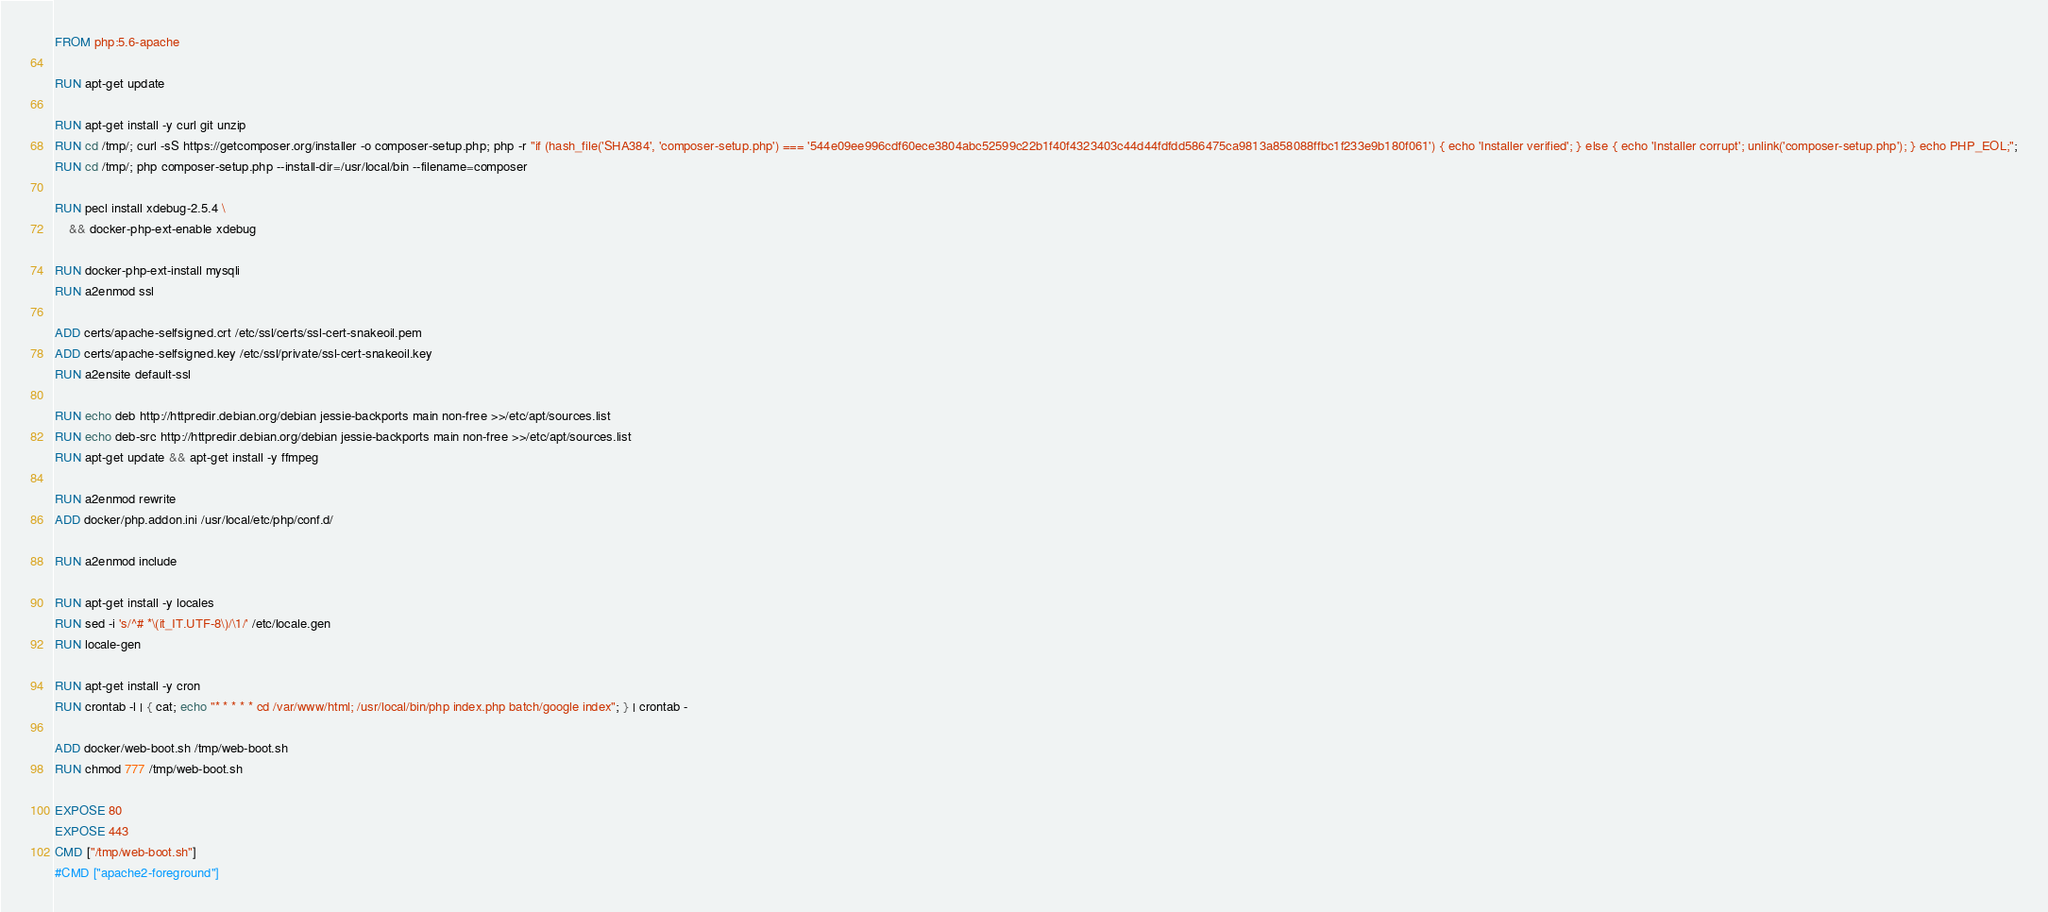<code> <loc_0><loc_0><loc_500><loc_500><_Dockerfile_>FROM php:5.6-apache

RUN apt-get update

RUN apt-get install -y curl git unzip
RUN cd /tmp/; curl -sS https://getcomposer.org/installer -o composer-setup.php; php -r "if (hash_file('SHA384', 'composer-setup.php') === '544e09ee996cdf60ece3804abc52599c22b1f40f4323403c44d44fdfdd586475ca9813a858088ffbc1f233e9b180f061') { echo 'Installer verified'; } else { echo 'Installer corrupt'; unlink('composer-setup.php'); } echo PHP_EOL;";
RUN cd /tmp/; php composer-setup.php --install-dir=/usr/local/bin --filename=composer

RUN pecl install xdebug-2.5.4 \
    && docker-php-ext-enable xdebug

RUN docker-php-ext-install mysqli
RUN a2enmod ssl

ADD certs/apache-selfsigned.crt /etc/ssl/certs/ssl-cert-snakeoil.pem
ADD certs/apache-selfsigned.key /etc/ssl/private/ssl-cert-snakeoil.key
RUN a2ensite default-ssl

RUN echo deb http://httpredir.debian.org/debian jessie-backports main non-free >>/etc/apt/sources.list
RUN echo deb-src http://httpredir.debian.org/debian jessie-backports main non-free >>/etc/apt/sources.list
RUN apt-get update && apt-get install -y ffmpeg

RUN a2enmod rewrite
ADD docker/php.addon.ini /usr/local/etc/php/conf.d/

RUN a2enmod include

RUN apt-get install -y locales
RUN sed -i 's/^# *\(it_IT.UTF-8\)/\1/' /etc/locale.gen
RUN locale-gen

RUN apt-get install -y cron
RUN crontab -l | { cat; echo "* * * * * cd /var/www/html; /usr/local/bin/php index.php batch/google index"; } | crontab -

ADD docker/web-boot.sh /tmp/web-boot.sh
RUN chmod 777 /tmp/web-boot.sh

EXPOSE 80
EXPOSE 443
CMD ["/tmp/web-boot.sh"]
#CMD ["apache2-foreground"]</code> 